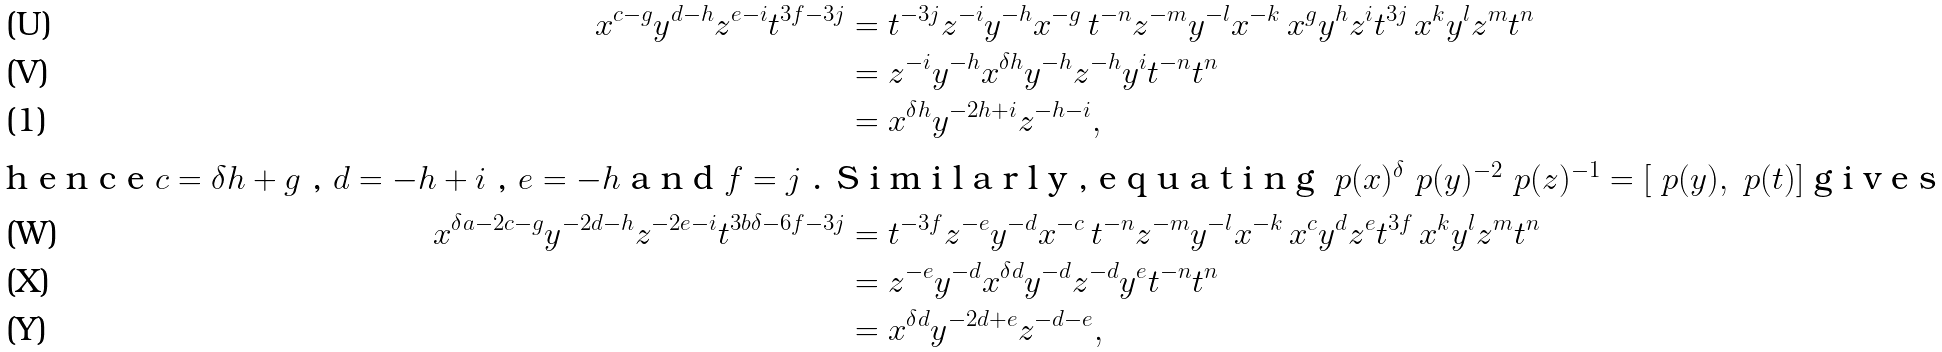<formula> <loc_0><loc_0><loc_500><loc_500>x ^ { c - g } y ^ { d - h } z ^ { e - i } t ^ { 3 f - 3 j } & = t ^ { - 3 j } z ^ { - i } y ^ { - h } x ^ { - g } \, t ^ { - n } z ^ { - m } y ^ { - l } x ^ { - k } \, x ^ { g } y ^ { h } z ^ { i } t ^ { 3 j } \, x ^ { k } y ^ { l } z ^ { m } t ^ { n } \\ & = z ^ { - i } y ^ { - h } x ^ { \delta h } y ^ { - h } z ^ { - h } y ^ { i } t ^ { - n } t ^ { n } \\ & = x ^ { \delta h } y ^ { - 2 h + i } z ^ { - h - i } , \intertext { h e n c e $ c = \delta h + g $ , $ d = - h + i $ , $ e = - h $ a n d $ f = j $ . S i m i l a r l y , e q u a t i n g $ \ p ( x ) ^ { \delta } \ p ( y ) ^ { - 2 } \ p ( z ) ^ { - 1 } = [ \ p ( y ) , \ p ( t ) ] $ g i v e s } x ^ { \delta a - 2 c - g } y ^ { - 2 d - h } z ^ { - 2 e - i } t ^ { 3 b \delta - 6 f - 3 j } & = t ^ { - 3 f } z ^ { - e } y ^ { - d } x ^ { - c } \, t ^ { - n } z ^ { - m } y ^ { - l } x ^ { - k } \, x ^ { c } y ^ { d } z ^ { e } t ^ { 3 f } \, x ^ { k } y ^ { l } z ^ { m } t ^ { n } \\ & = z ^ { - e } y ^ { - d } x ^ { \delta d } y ^ { - d } z ^ { - d } y ^ { e } t ^ { - n } t ^ { n } \\ & = x ^ { \delta d } y ^ { - 2 d + e } z ^ { - d - e } ,</formula> 